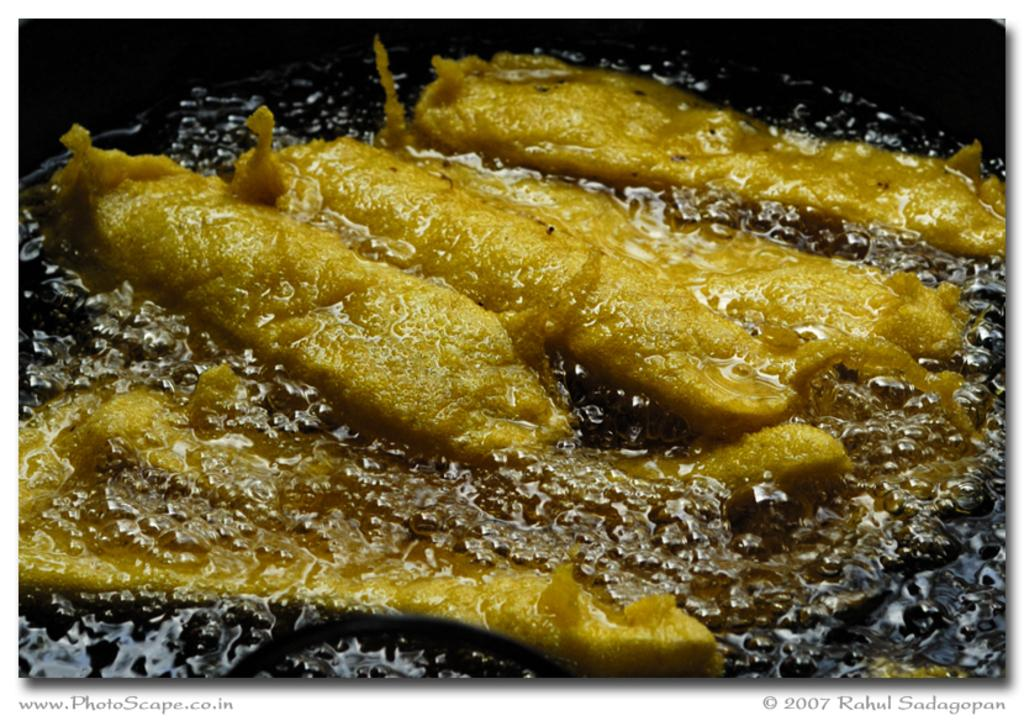What is the main subject of the image? The main subject of the image is a food item. What is happening to the food item in the image? The food item is frying in oil. What type of crown is being worn by the governor during the battle in the image? There is no governor, battle, or crown present in the image; it only features a food item frying in oil. 